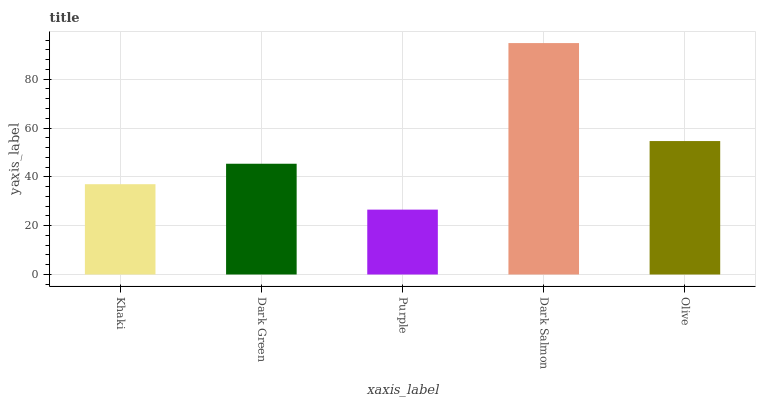Is Dark Green the minimum?
Answer yes or no. No. Is Dark Green the maximum?
Answer yes or no. No. Is Dark Green greater than Khaki?
Answer yes or no. Yes. Is Khaki less than Dark Green?
Answer yes or no. Yes. Is Khaki greater than Dark Green?
Answer yes or no. No. Is Dark Green less than Khaki?
Answer yes or no. No. Is Dark Green the high median?
Answer yes or no. Yes. Is Dark Green the low median?
Answer yes or no. Yes. Is Dark Salmon the high median?
Answer yes or no. No. Is Purple the low median?
Answer yes or no. No. 